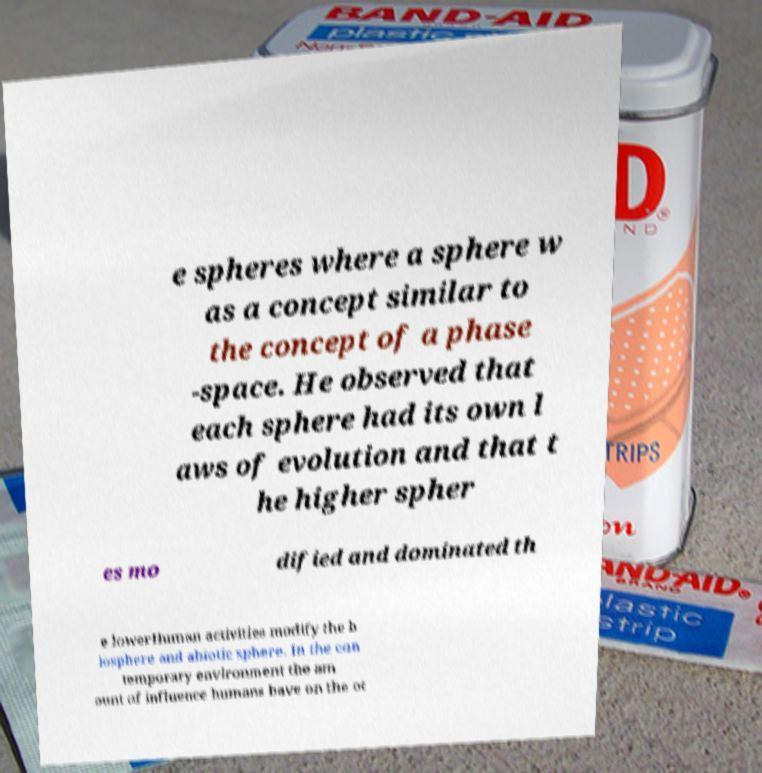Can you read and provide the text displayed in the image?This photo seems to have some interesting text. Can you extract and type it out for me? e spheres where a sphere w as a concept similar to the concept of a phase -space. He observed that each sphere had its own l aws of evolution and that t he higher spher es mo dified and dominated th e lowerHuman activities modify the b iosphere and abiotic sphere. In the con temporary environment the am ount of influence humans have on the ot 